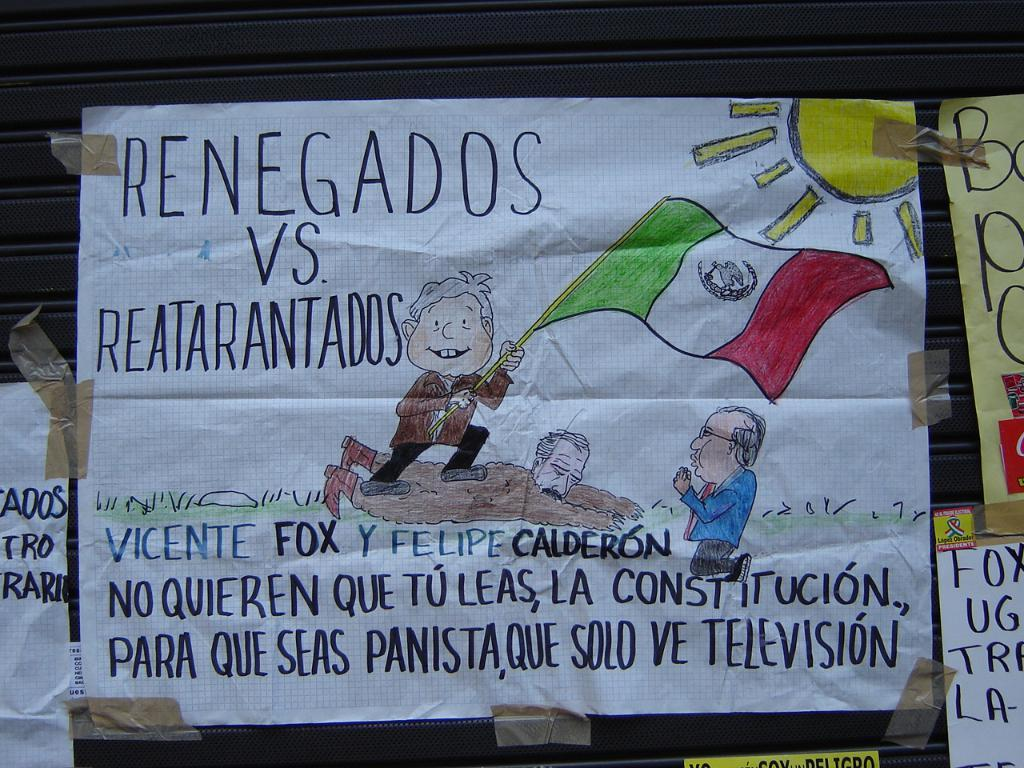<image>
Give a short and clear explanation of the subsequent image. A hand-drawn side shows a man holding a Mexican flag standing on another man and mentions Vicente Fox. 